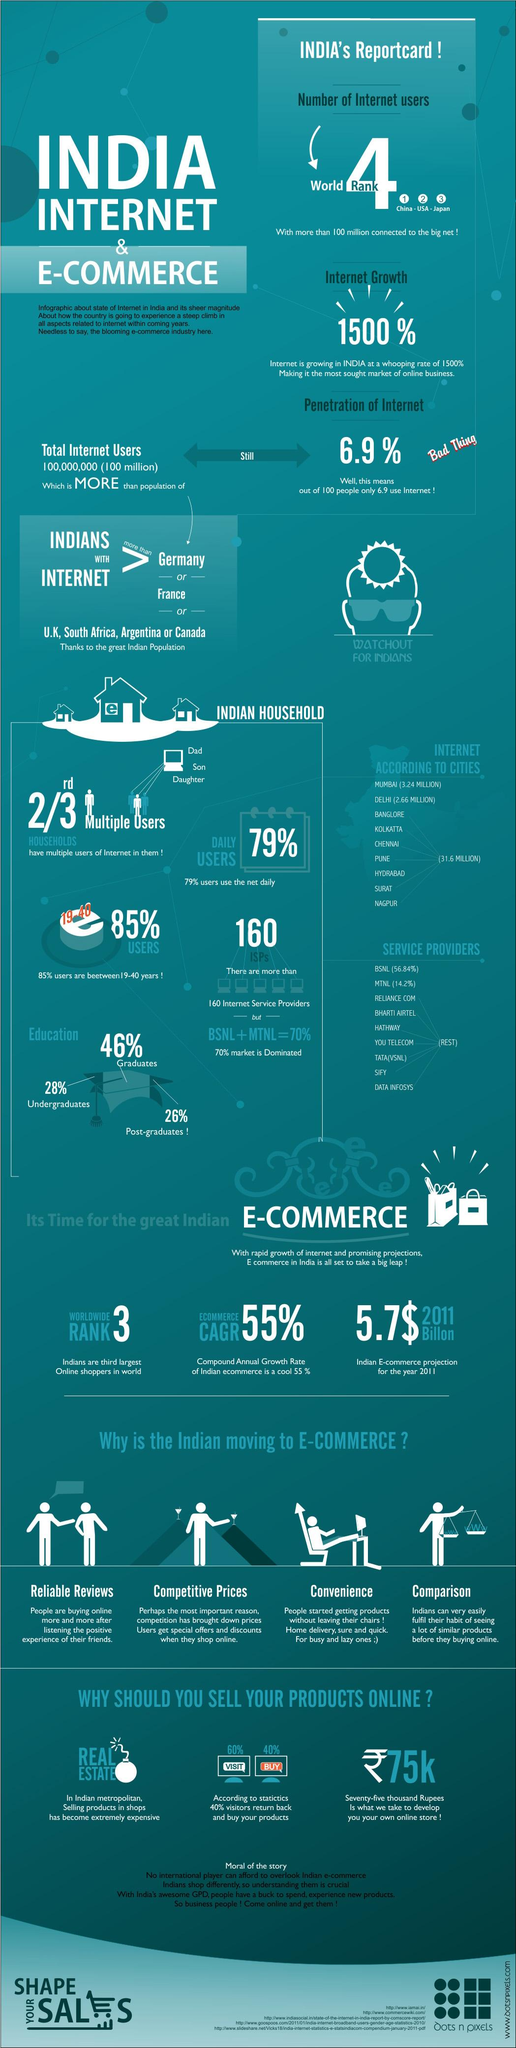Identify some key points in this picture. According to a recent survey, 21% of users do not use the internet every day. Only six countries have fewer internet users than India. The United States of America holds the second rank in internet usage. The group of internet users based on education that use the internet the most are graduates, followed by undergraduates and post-graduates. 